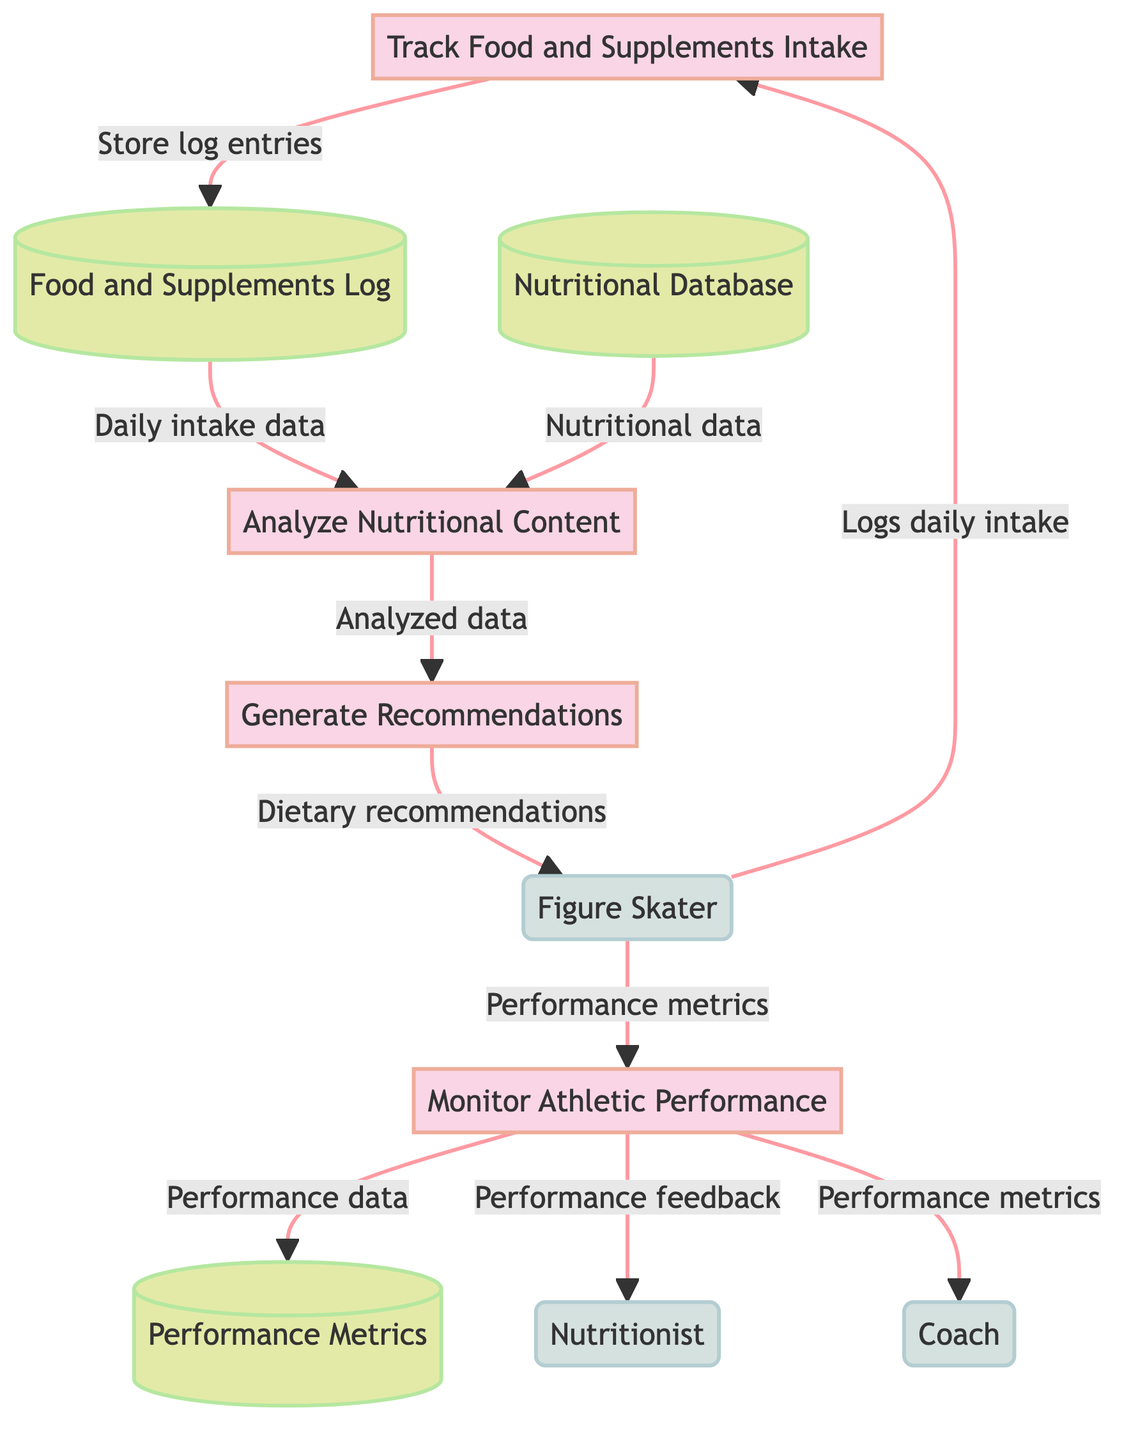What is the main process that logs daily food intake? The diagram shows that "Track Food and Supplements Intake" is the process responsible for logging daily food intake. This is evident as it is the first process and directly receives input from the Figure Skater.
Answer: Track Food and Supplements Intake How many data stores are present in the diagram? The diagram has three data stores: "Food and Supplements Log," "Nutritional Database," and "Performance Metrics." Each is represented distinctly with connections to various processes.
Answer: 3 Which process generates dietary recommendations? The process labeled "Generate Recommendations" is specifically designated to create dietary suggestions based on the analysis provided by the previous step. It is directly connected to both the process of analyzing nutritional content and the output to the Figure Skater.
Answer: Generate Recommendations What is the relationship between "Analyze Nutritional Content" and "Food and Supplements Log"? "Analyze Nutritional Content" receives daily intake data directly from "Food and Supplements Log," which is crucial for performing the analysis to evaluate nutritional values. This relationship shows that the analysis process depends on the information stored in the log.
Answer: Daily intake data Who provides performance feedback for dietary planning? The "Nutritionist" receives performance feedback from the "Monitor Athletic Performance" process, indicating their role in dietary planning based on the performance data. This connection is essential for tailoring nutritional advice to the athlete's needs.
Answer: Nutritionist What is the role of the Coach in this process? The Coach receives performance metrics from the "Monitor Athletic Performance" process, which implies their responsibility for making training adjustments based on the athlete's performance in relation to their nutrition. This indicates a feedback loop for improving both nutrition and training.
Answer: Performance metrics What type of data is stored in the Nutritional Database? The "Nutritional Database" contains nutritional information of common foods and supplements, which is essential for evaluating the nutritional values in the analysis phase of the process. This stored data influences the recommendations made for dietary strategies.
Answer: Nutritional information Which entity logs food intake? The "Figure Skater" is the entity responsible for logging food intake, as explicitly stated in the diagram. This action initiates the entire process flow concerning nutrition and supplementation.
Answer: Figure Skater What does the "Monitor Athletic Performance" process depend on? The "Monitor Athletic Performance" process depends on performance metrics, which it logs and monitors. This is a critical part of understanding how nutrition influences athletic performance and making adjustments based on this data.
Answer: Performance metrics 